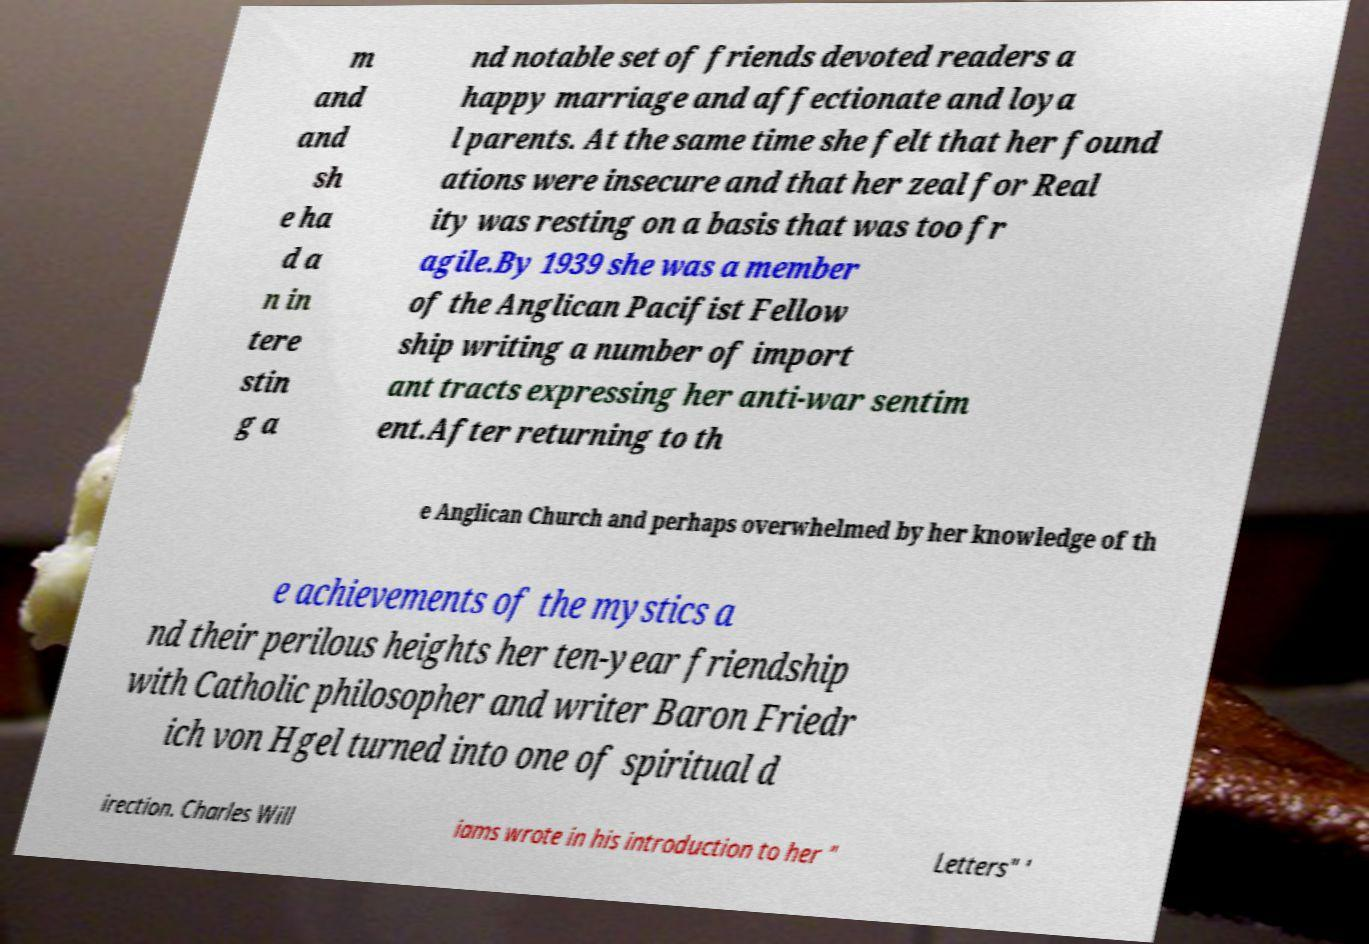What messages or text are displayed in this image? I need them in a readable, typed format. m and and sh e ha d a n in tere stin g a nd notable set of friends devoted readers a happy marriage and affectionate and loya l parents. At the same time she felt that her found ations were insecure and that her zeal for Real ity was resting on a basis that was too fr agile.By 1939 she was a member of the Anglican Pacifist Fellow ship writing a number of import ant tracts expressing her anti-war sentim ent.After returning to th e Anglican Church and perhaps overwhelmed by her knowledge of th e achievements of the mystics a nd their perilous heights her ten-year friendship with Catholic philosopher and writer Baron Friedr ich von Hgel turned into one of spiritual d irection. Charles Will iams wrote in his introduction to her " Letters" ' 